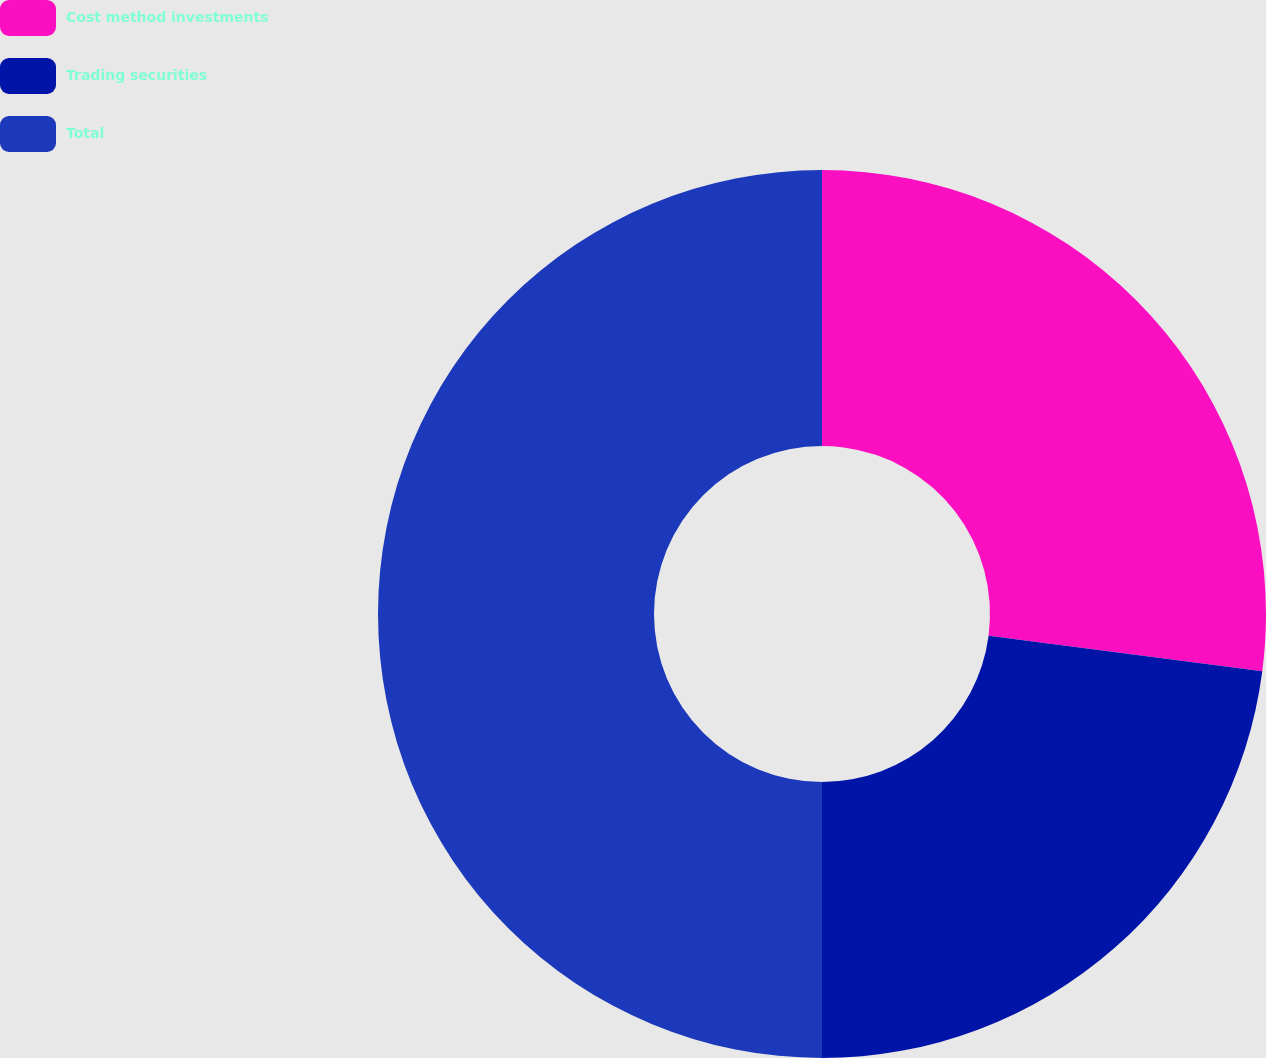<chart> <loc_0><loc_0><loc_500><loc_500><pie_chart><fcel>Cost method investments<fcel>Trading securities<fcel>Total<nl><fcel>27.06%<fcel>22.94%<fcel>50.0%<nl></chart> 